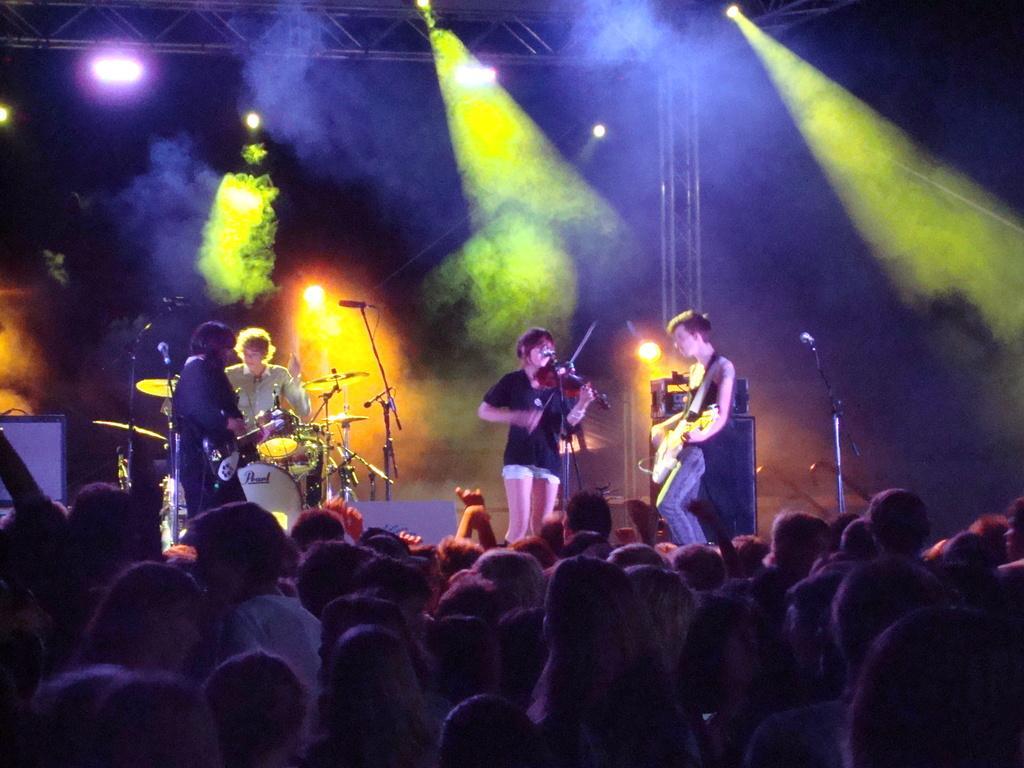Can you describe this image briefly? This picture consists of crowd at the bottom , in the middle I can see there are persons holding musical instrument and some musical instruments visible beside persons and there are colorful lights and stands visible at the top. 